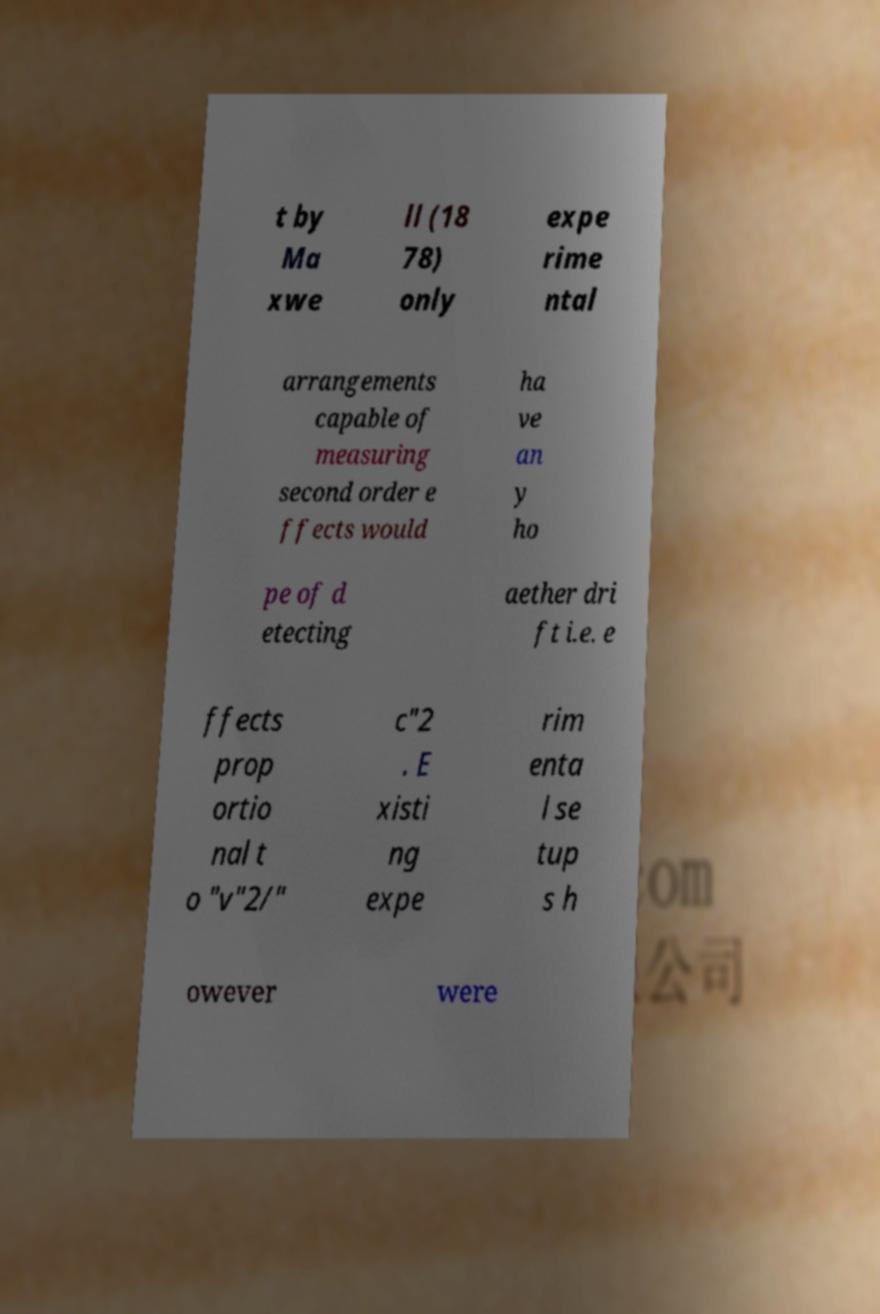Can you accurately transcribe the text from the provided image for me? t by Ma xwe ll (18 78) only expe rime ntal arrangements capable of measuring second order e ffects would ha ve an y ho pe of d etecting aether dri ft i.e. e ffects prop ortio nal t o "v"2/" c"2 . E xisti ng expe rim enta l se tup s h owever were 